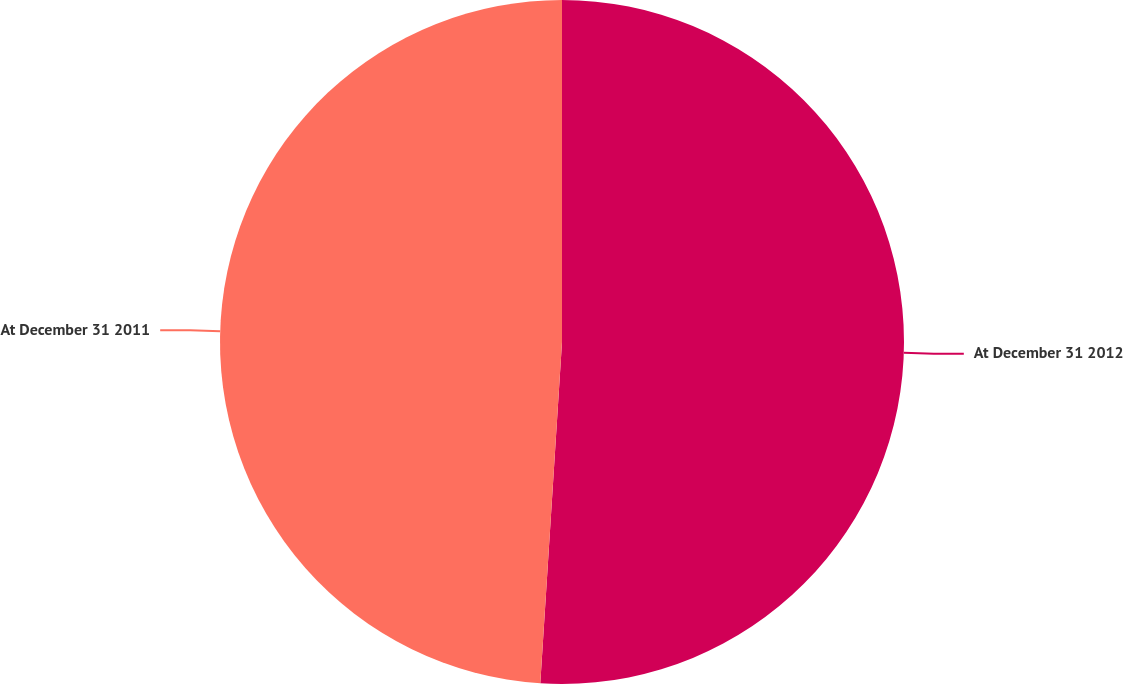Convert chart to OTSL. <chart><loc_0><loc_0><loc_500><loc_500><pie_chart><fcel>At December 31 2012<fcel>At December 31 2011<nl><fcel>51.01%<fcel>48.99%<nl></chart> 